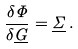<formula> <loc_0><loc_0><loc_500><loc_500>\frac { \delta \Phi } { \delta \underline { G } } = \underline { \Sigma } \, .</formula> 